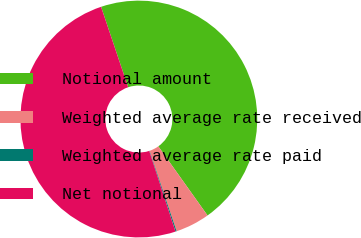Convert chart to OTSL. <chart><loc_0><loc_0><loc_500><loc_500><pie_chart><fcel>Notional amount<fcel>Weighted average rate received<fcel>Weighted average rate paid<fcel>Net notional<nl><fcel>45.32%<fcel>4.68%<fcel>0.16%<fcel>49.84%<nl></chart> 